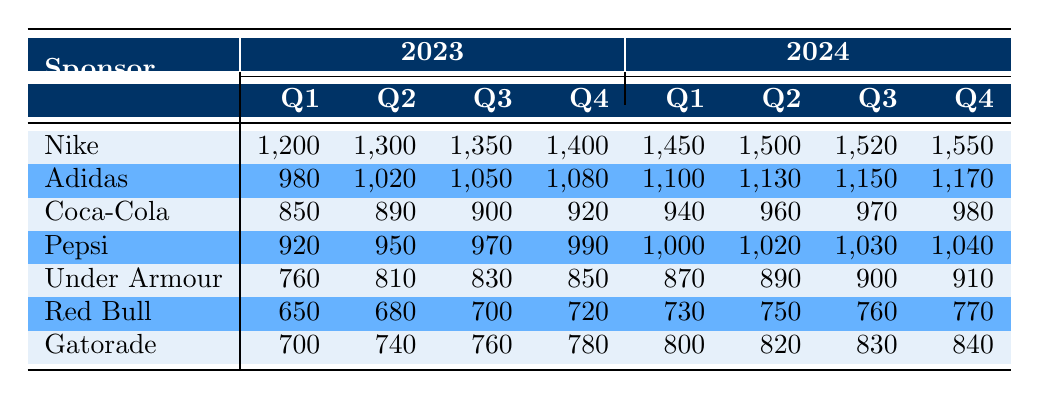What was the revenue from Nike in Q2 of 2023? Looking at the table under the "2023" column, the row for Nike reveals that the revenue for Q2 is 1,300.
Answer: 1,300 Which sponsor generated the lowest revenue in Q1 of 2024? In the Q1 of 2024 column, comparing all revenues, Red Bull has the lowest revenue at 730.
Answer: 730 What is the total revenue from Adidas for all quarters in 2023? Summing the Adidas revenue for Q1 (980), Q2 (1,020), Q3 (1,050), and Q4 (1,080) gives 980 + 1,020 + 1,050 + 1,080 = 4,130.
Answer: 4,130 Is it true that Gatorade's revenue increased in every quarter from 2023 to 2024? By checking the Gatorade values for each quarter: Q1 (700 to 800), Q2 (740 to 820), Q3 (760 to 830), Q4 (780 to 840), all values confirm an increase each quarter, thus the statement is true.
Answer: Yes What was the difference in revenue from Pepsi between Q1 of 2023 and Q1 of 2024? The revenue from Pepsi in Q1 of 2023 is 920, and in Q1 of 2024 it is 1,000. Calculating the difference: 1,000 - 920 = 80.
Answer: 80 What was the average revenue for Coca-Cola across both years? The revenues for Coca-Cola are: Q1 (850), Q2 (890), Q3 (900), Q4 (920), Q1 (940), Q2 (960), Q3 (970), Q4 (980). Adding these gives 850 + 890 + 900 + 920 + 940 + 960 + 970 + 980 = 7,510, and dividing by 8 results in an average of 938.75.
Answer: 938.75 How much revenue did Under Armour generate in Q3 of 2024? Referencing the 2024 data, Under Armour’s revenue in Q3 is listed as 900.
Answer: 900 Which sponsor had the highest revenue in Q4 of 2023? Checking the Q4 values, Nike has the highest revenue at 1,400, more than any other sponsor listed.
Answer: 1,400 